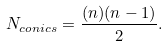<formula> <loc_0><loc_0><loc_500><loc_500>N _ { c o n i c s } = \frac { ( n ) ( n - 1 ) } { 2 } .</formula> 